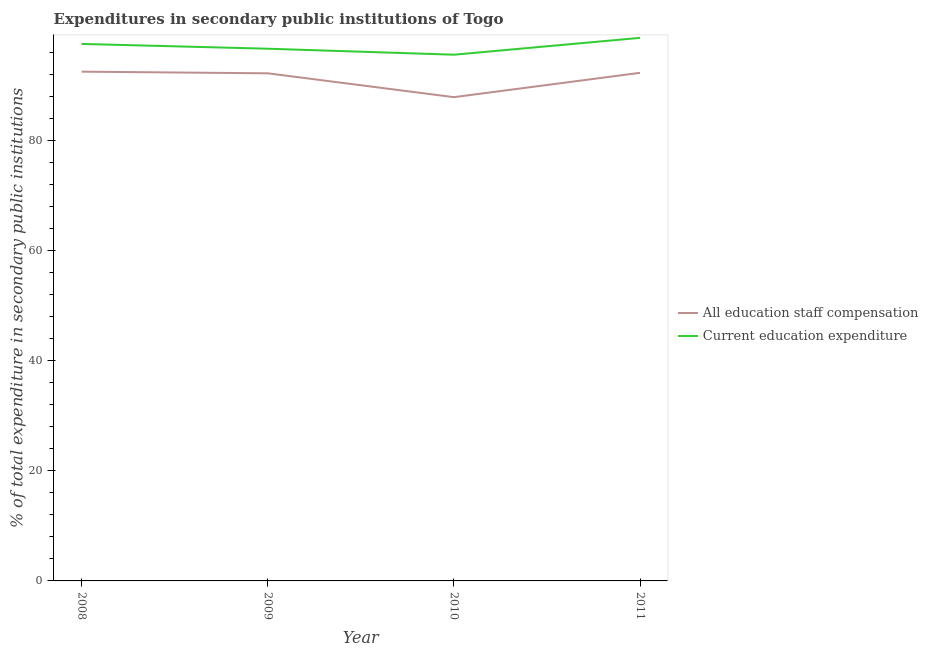How many different coloured lines are there?
Keep it short and to the point. 2. Is the number of lines equal to the number of legend labels?
Offer a very short reply. Yes. What is the expenditure in staff compensation in 2009?
Offer a terse response. 92.18. Across all years, what is the maximum expenditure in education?
Provide a succinct answer. 98.62. Across all years, what is the minimum expenditure in staff compensation?
Provide a short and direct response. 87.84. In which year was the expenditure in education minimum?
Offer a terse response. 2010. What is the total expenditure in education in the graph?
Your answer should be compact. 388.32. What is the difference between the expenditure in education in 2010 and that in 2011?
Keep it short and to the point. -3.06. What is the difference between the expenditure in education in 2010 and the expenditure in staff compensation in 2009?
Keep it short and to the point. 3.38. What is the average expenditure in staff compensation per year?
Offer a very short reply. 91.19. In the year 2010, what is the difference between the expenditure in staff compensation and expenditure in education?
Your response must be concise. -7.71. What is the ratio of the expenditure in staff compensation in 2009 to that in 2010?
Give a very brief answer. 1.05. Is the difference between the expenditure in education in 2009 and 2011 greater than the difference between the expenditure in staff compensation in 2009 and 2011?
Give a very brief answer. No. What is the difference between the highest and the second highest expenditure in staff compensation?
Make the answer very short. 0.21. What is the difference between the highest and the lowest expenditure in education?
Provide a short and direct response. 3.06. In how many years, is the expenditure in staff compensation greater than the average expenditure in staff compensation taken over all years?
Your response must be concise. 3. Is the sum of the expenditure in staff compensation in 2009 and 2010 greater than the maximum expenditure in education across all years?
Ensure brevity in your answer.  Yes. How many years are there in the graph?
Provide a short and direct response. 4. What is the difference between two consecutive major ticks on the Y-axis?
Provide a short and direct response. 20. How many legend labels are there?
Offer a terse response. 2. How are the legend labels stacked?
Your answer should be compact. Vertical. What is the title of the graph?
Make the answer very short. Expenditures in secondary public institutions of Togo. Does "Official creditors" appear as one of the legend labels in the graph?
Your answer should be compact. No. What is the label or title of the Y-axis?
Make the answer very short. % of total expenditure in secondary public institutions. What is the % of total expenditure in secondary public institutions in All education staff compensation in 2008?
Your answer should be compact. 92.48. What is the % of total expenditure in secondary public institutions of Current education expenditure in 2008?
Make the answer very short. 97.51. What is the % of total expenditure in secondary public institutions of All education staff compensation in 2009?
Ensure brevity in your answer.  92.18. What is the % of total expenditure in secondary public institutions of Current education expenditure in 2009?
Provide a short and direct response. 96.64. What is the % of total expenditure in secondary public institutions of All education staff compensation in 2010?
Provide a short and direct response. 87.84. What is the % of total expenditure in secondary public institutions in Current education expenditure in 2010?
Offer a very short reply. 95.55. What is the % of total expenditure in secondary public institutions in All education staff compensation in 2011?
Keep it short and to the point. 92.26. What is the % of total expenditure in secondary public institutions of Current education expenditure in 2011?
Give a very brief answer. 98.62. Across all years, what is the maximum % of total expenditure in secondary public institutions of All education staff compensation?
Keep it short and to the point. 92.48. Across all years, what is the maximum % of total expenditure in secondary public institutions of Current education expenditure?
Make the answer very short. 98.62. Across all years, what is the minimum % of total expenditure in secondary public institutions in All education staff compensation?
Your answer should be compact. 87.84. Across all years, what is the minimum % of total expenditure in secondary public institutions of Current education expenditure?
Provide a short and direct response. 95.55. What is the total % of total expenditure in secondary public institutions in All education staff compensation in the graph?
Keep it short and to the point. 364.76. What is the total % of total expenditure in secondary public institutions of Current education expenditure in the graph?
Offer a terse response. 388.32. What is the difference between the % of total expenditure in secondary public institutions in All education staff compensation in 2008 and that in 2009?
Ensure brevity in your answer.  0.3. What is the difference between the % of total expenditure in secondary public institutions in Current education expenditure in 2008 and that in 2009?
Your answer should be compact. 0.87. What is the difference between the % of total expenditure in secondary public institutions of All education staff compensation in 2008 and that in 2010?
Keep it short and to the point. 4.63. What is the difference between the % of total expenditure in secondary public institutions in Current education expenditure in 2008 and that in 2010?
Your answer should be very brief. 1.96. What is the difference between the % of total expenditure in secondary public institutions of All education staff compensation in 2008 and that in 2011?
Make the answer very short. 0.21. What is the difference between the % of total expenditure in secondary public institutions of Current education expenditure in 2008 and that in 2011?
Provide a succinct answer. -1.11. What is the difference between the % of total expenditure in secondary public institutions of All education staff compensation in 2009 and that in 2010?
Your answer should be compact. 4.33. What is the difference between the % of total expenditure in secondary public institutions of Current education expenditure in 2009 and that in 2010?
Give a very brief answer. 1.09. What is the difference between the % of total expenditure in secondary public institutions of All education staff compensation in 2009 and that in 2011?
Your answer should be compact. -0.09. What is the difference between the % of total expenditure in secondary public institutions in Current education expenditure in 2009 and that in 2011?
Your response must be concise. -1.98. What is the difference between the % of total expenditure in secondary public institutions of All education staff compensation in 2010 and that in 2011?
Your answer should be very brief. -4.42. What is the difference between the % of total expenditure in secondary public institutions in Current education expenditure in 2010 and that in 2011?
Give a very brief answer. -3.06. What is the difference between the % of total expenditure in secondary public institutions of All education staff compensation in 2008 and the % of total expenditure in secondary public institutions of Current education expenditure in 2009?
Ensure brevity in your answer.  -4.16. What is the difference between the % of total expenditure in secondary public institutions of All education staff compensation in 2008 and the % of total expenditure in secondary public institutions of Current education expenditure in 2010?
Keep it short and to the point. -3.08. What is the difference between the % of total expenditure in secondary public institutions in All education staff compensation in 2008 and the % of total expenditure in secondary public institutions in Current education expenditure in 2011?
Keep it short and to the point. -6.14. What is the difference between the % of total expenditure in secondary public institutions in All education staff compensation in 2009 and the % of total expenditure in secondary public institutions in Current education expenditure in 2010?
Provide a short and direct response. -3.38. What is the difference between the % of total expenditure in secondary public institutions of All education staff compensation in 2009 and the % of total expenditure in secondary public institutions of Current education expenditure in 2011?
Offer a terse response. -6.44. What is the difference between the % of total expenditure in secondary public institutions in All education staff compensation in 2010 and the % of total expenditure in secondary public institutions in Current education expenditure in 2011?
Your answer should be compact. -10.77. What is the average % of total expenditure in secondary public institutions in All education staff compensation per year?
Keep it short and to the point. 91.19. What is the average % of total expenditure in secondary public institutions of Current education expenditure per year?
Your response must be concise. 97.08. In the year 2008, what is the difference between the % of total expenditure in secondary public institutions of All education staff compensation and % of total expenditure in secondary public institutions of Current education expenditure?
Ensure brevity in your answer.  -5.04. In the year 2009, what is the difference between the % of total expenditure in secondary public institutions of All education staff compensation and % of total expenditure in secondary public institutions of Current education expenditure?
Your answer should be very brief. -4.46. In the year 2010, what is the difference between the % of total expenditure in secondary public institutions of All education staff compensation and % of total expenditure in secondary public institutions of Current education expenditure?
Give a very brief answer. -7.71. In the year 2011, what is the difference between the % of total expenditure in secondary public institutions in All education staff compensation and % of total expenditure in secondary public institutions in Current education expenditure?
Provide a succinct answer. -6.35. What is the ratio of the % of total expenditure in secondary public institutions of All education staff compensation in 2008 to that in 2009?
Offer a very short reply. 1. What is the ratio of the % of total expenditure in secondary public institutions in Current education expenditure in 2008 to that in 2009?
Offer a terse response. 1.01. What is the ratio of the % of total expenditure in secondary public institutions of All education staff compensation in 2008 to that in 2010?
Provide a succinct answer. 1.05. What is the ratio of the % of total expenditure in secondary public institutions in Current education expenditure in 2008 to that in 2010?
Offer a terse response. 1.02. What is the ratio of the % of total expenditure in secondary public institutions in All education staff compensation in 2008 to that in 2011?
Make the answer very short. 1. What is the ratio of the % of total expenditure in secondary public institutions in All education staff compensation in 2009 to that in 2010?
Provide a succinct answer. 1.05. What is the ratio of the % of total expenditure in secondary public institutions in Current education expenditure in 2009 to that in 2010?
Provide a short and direct response. 1.01. What is the ratio of the % of total expenditure in secondary public institutions in All education staff compensation in 2010 to that in 2011?
Ensure brevity in your answer.  0.95. What is the ratio of the % of total expenditure in secondary public institutions of Current education expenditure in 2010 to that in 2011?
Offer a terse response. 0.97. What is the difference between the highest and the second highest % of total expenditure in secondary public institutions of All education staff compensation?
Your answer should be compact. 0.21. What is the difference between the highest and the second highest % of total expenditure in secondary public institutions in Current education expenditure?
Your answer should be compact. 1.11. What is the difference between the highest and the lowest % of total expenditure in secondary public institutions of All education staff compensation?
Your answer should be compact. 4.63. What is the difference between the highest and the lowest % of total expenditure in secondary public institutions of Current education expenditure?
Keep it short and to the point. 3.06. 